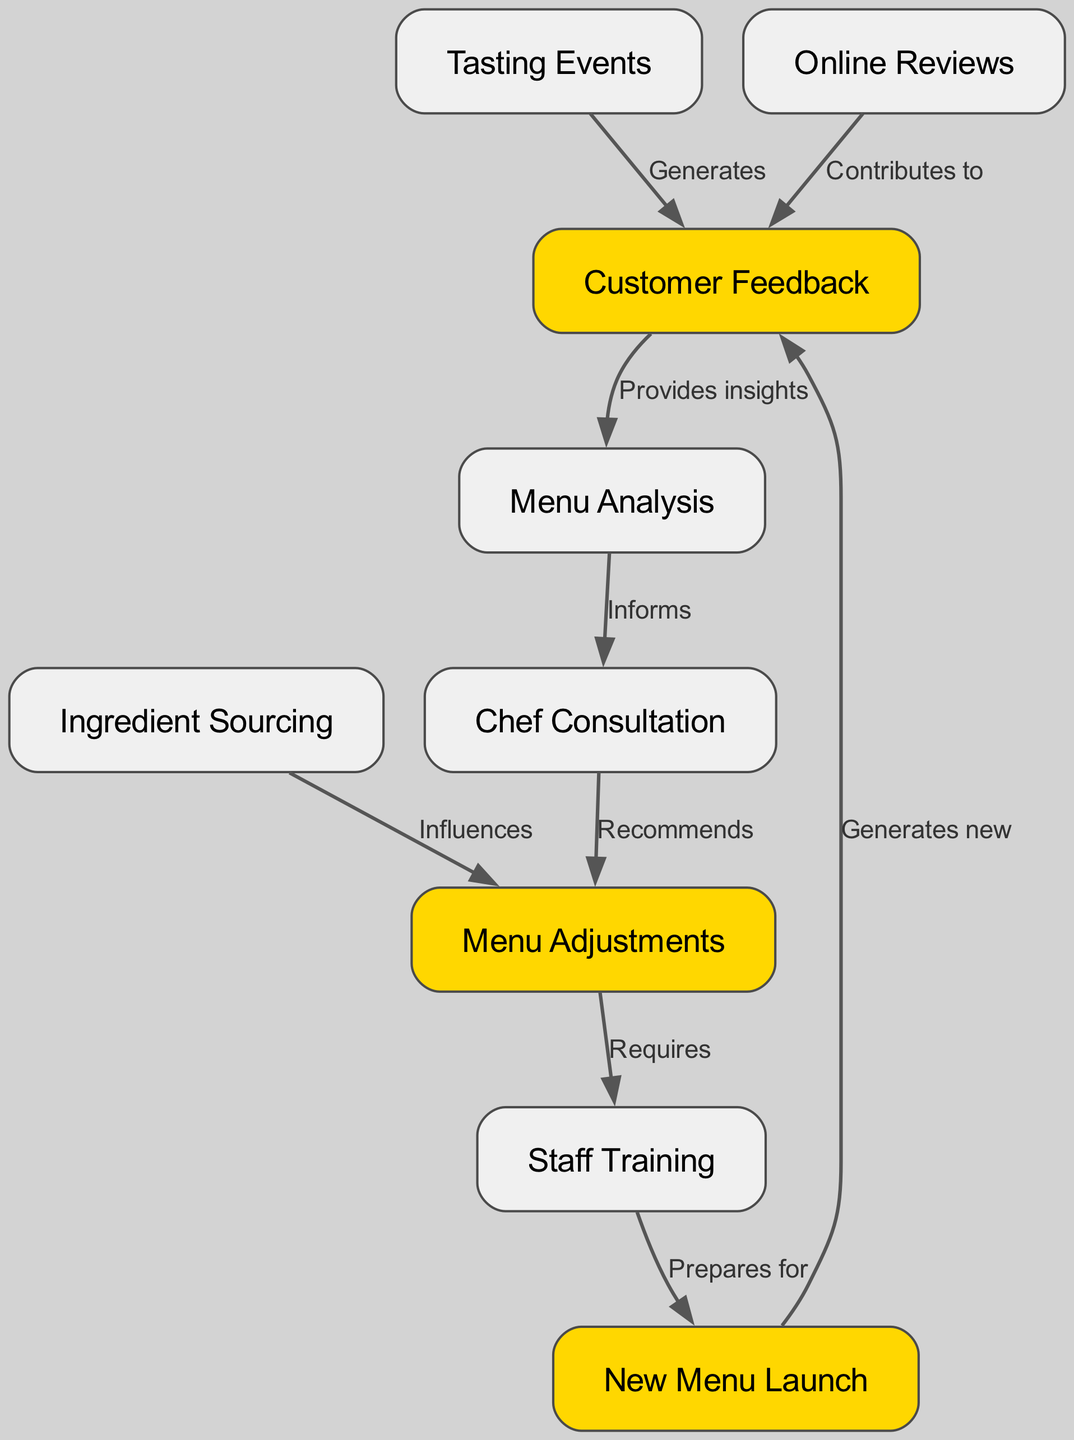What are the key nodes in this diagram? The key nodes highlighted in the diagram are "Customer Feedback", "Menu Adjustments", and "New Menu Launch". They are specially marked with a distinct color, indicating their significance in the process flow.
Answer: Customer Feedback, Menu Adjustments, New Menu Launch How many nodes are in the diagram? The diagram includes a total of 9 nodes that represent various stages and elements in the customer feedback flow and its impact on menu adjustments.
Answer: 9 What type of relationship does "Online Reviews" have with "Customer Feedback"? "Online Reviews" contributes to "Customer Feedback", indicating that feedback from online reviews helps shape the overall customer feedback input. This relationship is depicted as an edge pointing from "Online Reviews" to "Customer Feedback".
Answer: Contributes to What happens after "Menu Adjustments"? After "Menu Adjustments", the next step indicated in the flow is "Staff Training", suggesting that menu changes necessitate training for staff to ensure they can effectively implement the new menu items.
Answer: Staff Training How does "Tasting Events" influence "Customer Feedback"? "Tasting Events" generates "Customer Feedback", meaning the feedback collected during these events serves as a source of insights for the business. This is illustrated by an edge directed from "Tasting Events" towards "Customer Feedback".
Answer: Generates What node follows "Staff Training" in the flow? The node that follows "Staff Training" is "New Menu Launch", indicating that after staff training is completed, the business will proceed to launch the new menu to customers.
Answer: New Menu Launch What does "Menu Analysis" inform next in the process? "Menu Analysis" informs "Chef Consultation", indicating that the analysis of customer feedback and menu performance is critical for consulting with the chef about potential adjustments.
Answer: Chef Consultation Which node influences "Menu Adjustments"? "Ingredient Sourcing" influences "Menu Adjustments", suggesting that the ingredients available and sourced for the menu have a direct impact on how the menu can be adjusted or tailored.
Answer: Influences What cycle starts after the "New Menu Launch"? The cycle that starts after the "New Menu Launch" is "Customer Feedback", indicating that each new menu launch generates feedback, which will eventually loop back into the analysis and adjustment process.
Answer: Generates new 